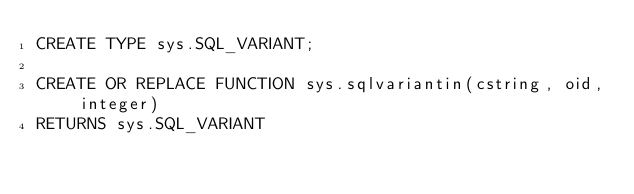<code> <loc_0><loc_0><loc_500><loc_500><_SQL_>CREATE TYPE sys.SQL_VARIANT;

CREATE OR REPLACE FUNCTION sys.sqlvariantin(cstring, oid, integer)
RETURNS sys.SQL_VARIANT</code> 